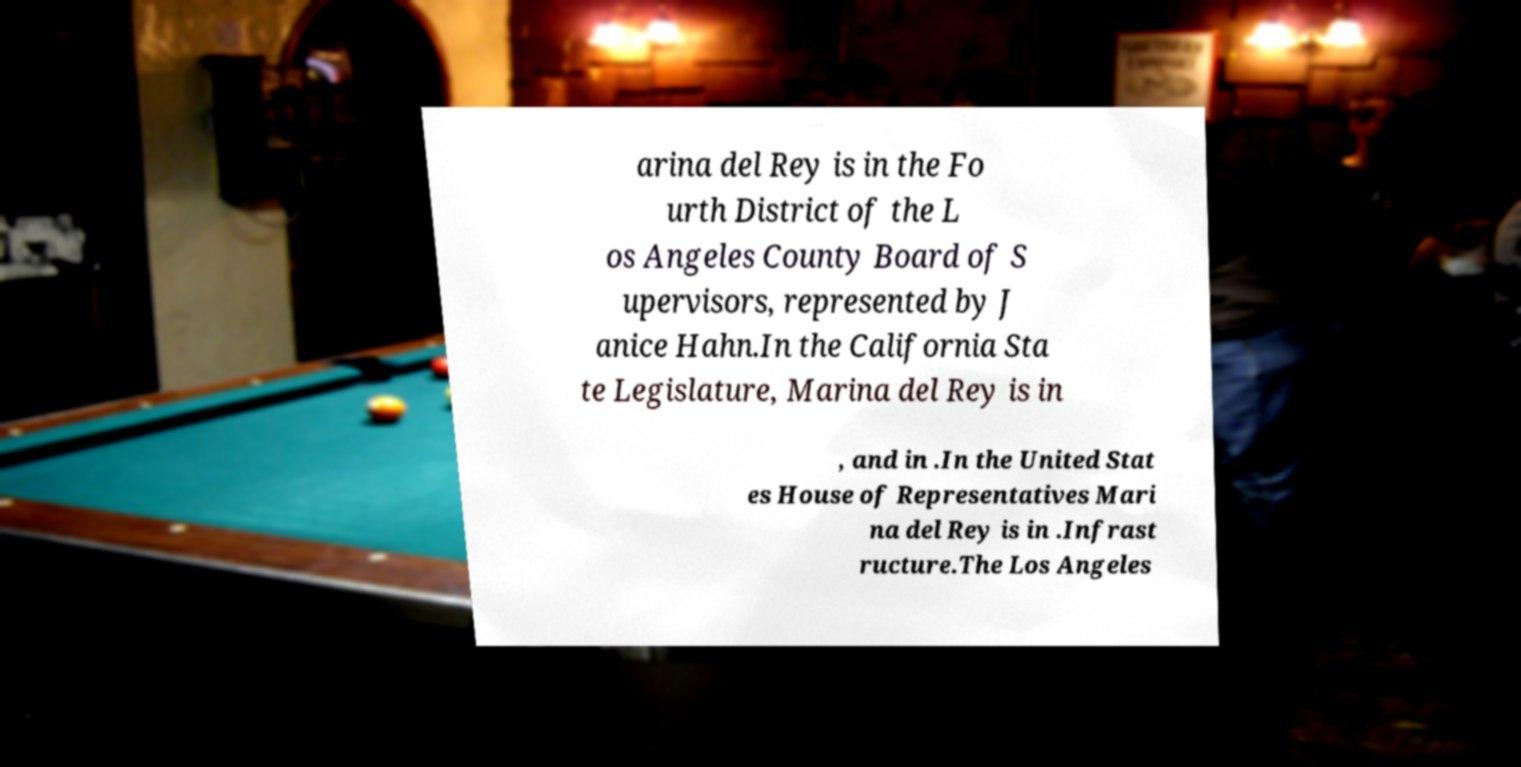There's text embedded in this image that I need extracted. Can you transcribe it verbatim? arina del Rey is in the Fo urth District of the L os Angeles County Board of S upervisors, represented by J anice Hahn.In the California Sta te Legislature, Marina del Rey is in , and in .In the United Stat es House of Representatives Mari na del Rey is in .Infrast ructure.The Los Angeles 